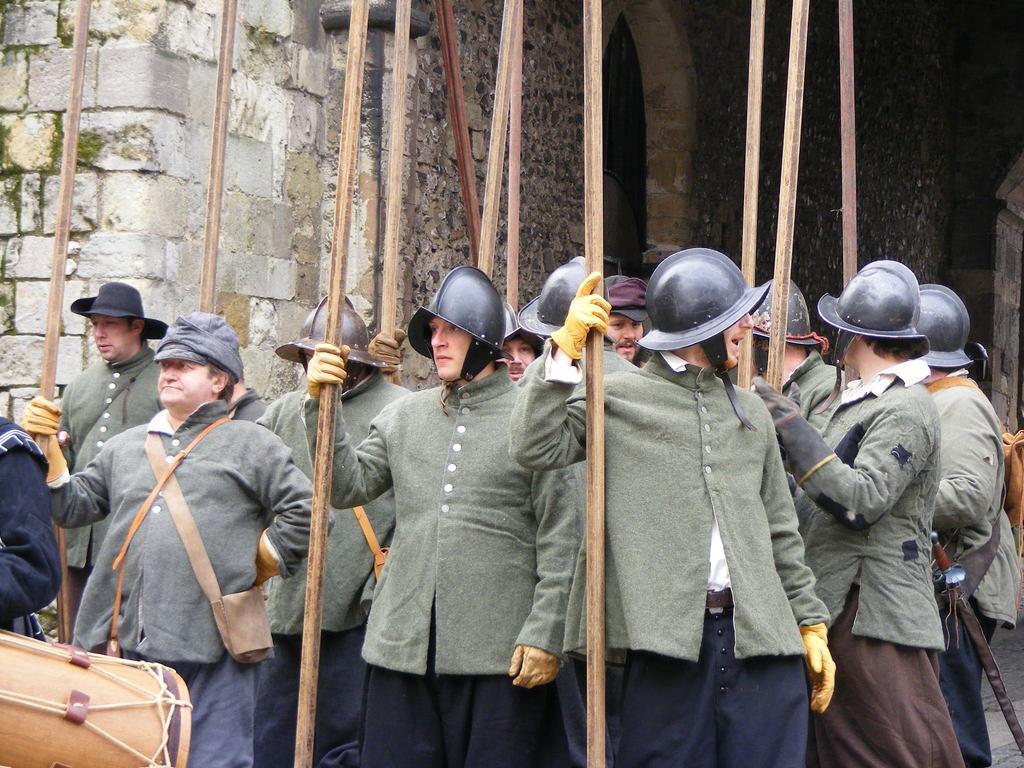Please provide a concise description of this image. In this picture we can see a group of people, they are holding sticks, some people are wearing helmets, some people are wearing caps, one person is wearing a hat and we can see a wall in the background. 